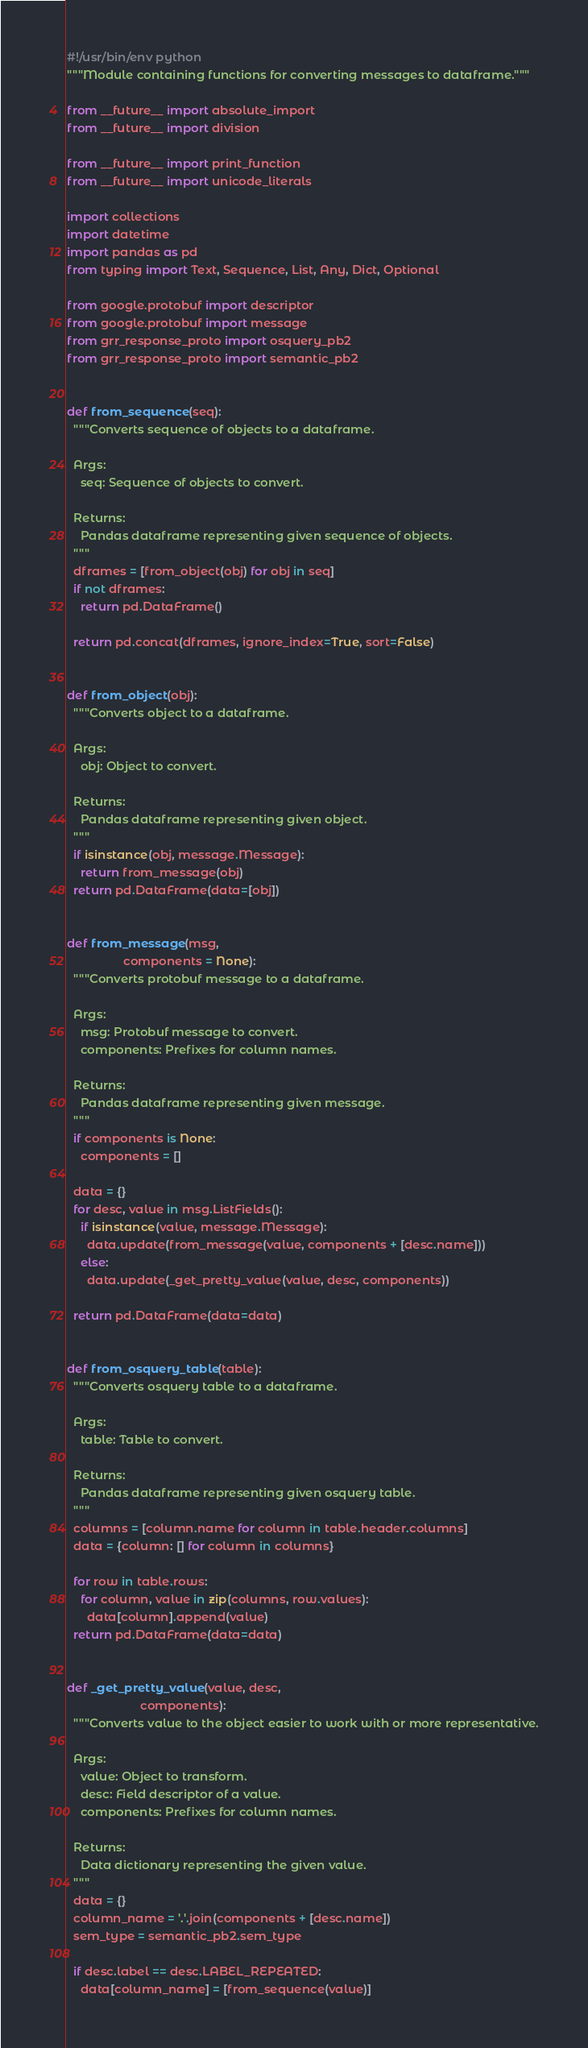<code> <loc_0><loc_0><loc_500><loc_500><_Python_>#!/usr/bin/env python
"""Module containing functions for converting messages to dataframe."""

from __future__ import absolute_import
from __future__ import division

from __future__ import print_function
from __future__ import unicode_literals

import collections
import datetime
import pandas as pd
from typing import Text, Sequence, List, Any, Dict, Optional

from google.protobuf import descriptor
from google.protobuf import message
from grr_response_proto import osquery_pb2
from grr_response_proto import semantic_pb2


def from_sequence(seq):
  """Converts sequence of objects to a dataframe.

  Args:
    seq: Sequence of objects to convert.

  Returns:
    Pandas dataframe representing given sequence of objects.
  """
  dframes = [from_object(obj) for obj in seq]
  if not dframes:
    return pd.DataFrame()

  return pd.concat(dframes, ignore_index=True, sort=False)


def from_object(obj):
  """Converts object to a dataframe.

  Args:
    obj: Object to convert.

  Returns:
    Pandas dataframe representing given object.
  """
  if isinstance(obj, message.Message):
    return from_message(obj)
  return pd.DataFrame(data=[obj])


def from_message(msg,
                 components = None):
  """Converts protobuf message to a dataframe.

  Args:
    msg: Protobuf message to convert.
    components: Prefixes for column names.

  Returns:
    Pandas dataframe representing given message.
  """
  if components is None:
    components = []

  data = {}
  for desc, value in msg.ListFields():
    if isinstance(value, message.Message):
      data.update(from_message(value, components + [desc.name]))
    else:
      data.update(_get_pretty_value(value, desc, components))

  return pd.DataFrame(data=data)


def from_osquery_table(table):
  """Converts osquery table to a dataframe.

  Args:
    table: Table to convert.

  Returns:
    Pandas dataframe representing given osquery table.
  """
  columns = [column.name for column in table.header.columns]
  data = {column: [] for column in columns}

  for row in table.rows:
    for column, value in zip(columns, row.values):
      data[column].append(value)
  return pd.DataFrame(data=data)


def _get_pretty_value(value, desc,
                      components):
  """Converts value to the object easier to work with or more representative.

  Args:
    value: Object to transform.
    desc: Field descriptor of a value.
    components: Prefixes for column names.

  Returns:
    Data dictionary representing the given value.
  """
  data = {}
  column_name = '.'.join(components + [desc.name])
  sem_type = semantic_pb2.sem_type

  if desc.label == desc.LABEL_REPEATED:
    data[column_name] = [from_sequence(value)]
</code> 